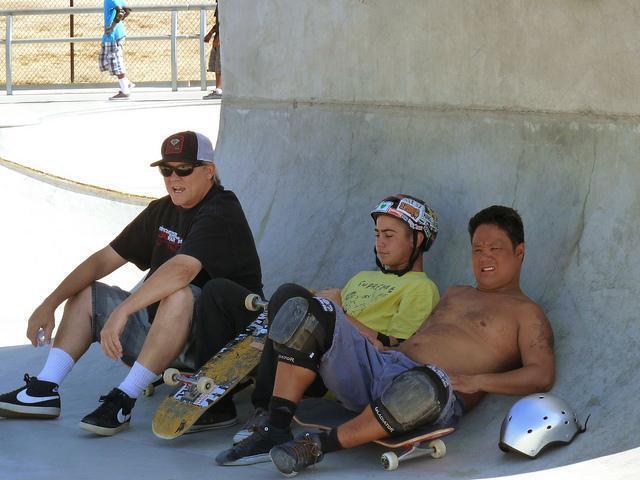How many skateboards are in the picture?
Give a very brief answer. 2. How many people are visible?
Give a very brief answer. 4. 